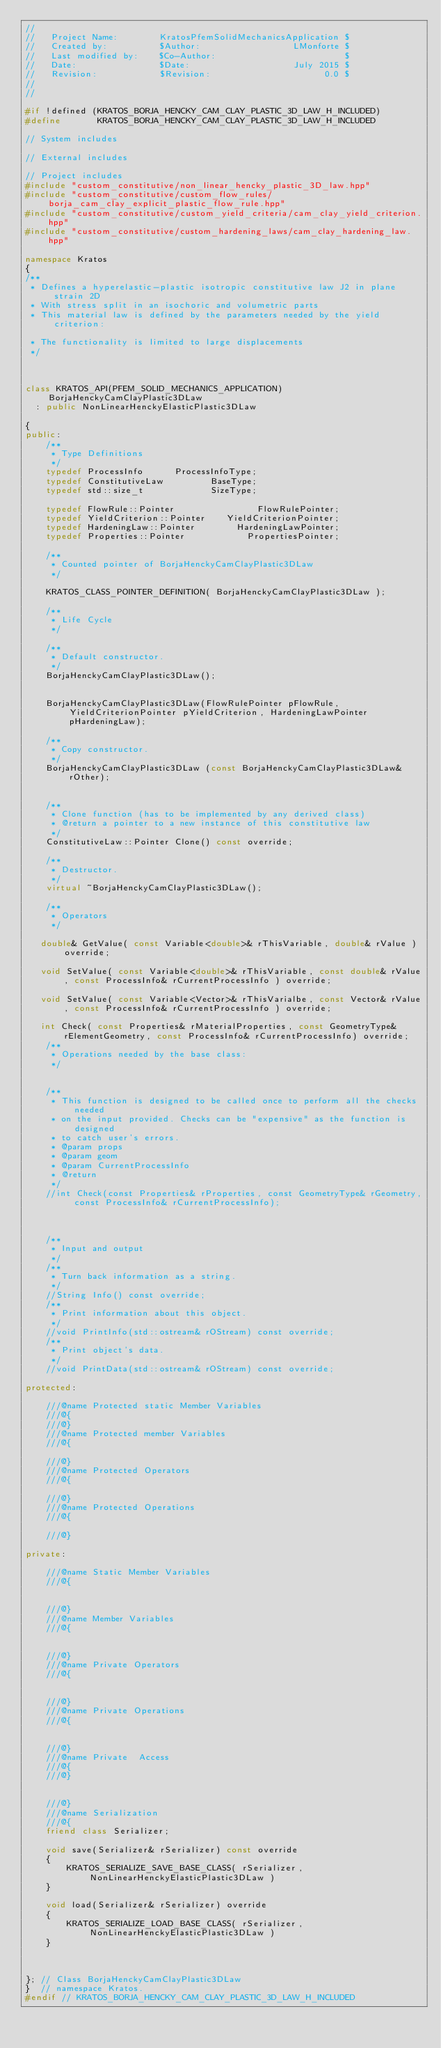Convert code to text. <code><loc_0><loc_0><loc_500><loc_500><_C++_>//
//   Project Name:        KratosPfemSolidMechanicsApplication $
//   Created by:          $Author:                  LMonforte $
//   Last modified by:    $Co-Author:                         $
//   Date:                $Date:                    July 2015 $
//   Revision:            $Revision:                      0.0 $
//
//

#if !defined (KRATOS_BORJA_HENCKY_CAM_CLAY_PLASTIC_3D_LAW_H_INCLUDED)
#define       KRATOS_BORJA_HENCKY_CAM_CLAY_PLASTIC_3D_LAW_H_INCLUDED

// System includes

// External includes

// Project includes
#include "custom_constitutive/non_linear_hencky_plastic_3D_law.hpp"
#include "custom_constitutive/custom_flow_rules/borja_cam_clay_explicit_plastic_flow_rule.hpp"
#include "custom_constitutive/custom_yield_criteria/cam_clay_yield_criterion.hpp"
#include "custom_constitutive/custom_hardening_laws/cam_clay_hardening_law.hpp"

namespace Kratos
{
/**
 * Defines a hyperelastic-plastic isotropic constitutive law J2 in plane strain 2D
 * With stress split in an isochoric and volumetric parts
 * This material law is defined by the parameters needed by the yield criterion:

 * The functionality is limited to large displacements
 */



class KRATOS_API(PFEM_SOLID_MECHANICS_APPLICATION) BorjaHenckyCamClayPlastic3DLaw
  : public NonLinearHenckyElasticPlastic3DLaw

{
public:
    /**
     * Type Definitions
     */
    typedef ProcessInfo      ProcessInfoType;
    typedef ConstitutiveLaw         BaseType;
    typedef std::size_t             SizeType;

    typedef FlowRule::Pointer                FlowRulePointer;
    typedef YieldCriterion::Pointer    YieldCriterionPointer;
    typedef HardeningLaw::Pointer        HardeningLawPointer;
    typedef Properties::Pointer            PropertiesPointer;

    /**
     * Counted pointer of BorjaHenckyCamClayPlastic3DLaw
     */

    KRATOS_CLASS_POINTER_DEFINITION( BorjaHenckyCamClayPlastic3DLaw );

    /**
     * Life Cycle
     */

    /**
     * Default constructor.
     */
    BorjaHenckyCamClayPlastic3DLaw();


    BorjaHenckyCamClayPlastic3DLaw(FlowRulePointer pFlowRule, YieldCriterionPointer pYieldCriterion, HardeningLawPointer pHardeningLaw);

    /**
     * Copy constructor.
     */
    BorjaHenckyCamClayPlastic3DLaw (const BorjaHenckyCamClayPlastic3DLaw& rOther);


    /**
     * Clone function (has to be implemented by any derived class)
     * @return a pointer to a new instance of this constitutive law
     */
    ConstitutiveLaw::Pointer Clone() const override;

    /**
     * Destructor.
     */
    virtual ~BorjaHenckyCamClayPlastic3DLaw();

    /**
     * Operators
     */

   double& GetValue( const Variable<double>& rThisVariable, double& rValue ) override;

   void SetValue( const Variable<double>& rThisVariable, const double& rValue, const ProcessInfo& rCurrentProcessInfo ) override;

   void SetValue( const Variable<Vector>& rThisVarialbe, const Vector& rValue, const ProcessInfo& rCurrentProcessInfo ) override;

   int Check( const Properties& rMaterialProperties, const GeometryType& rElementGeometry, const ProcessInfo& rCurrentProcessInfo) override;
    /**
     * Operations needed by the base class:
     */


    /**
     * This function is designed to be called once to perform all the checks needed
     * on the input provided. Checks can be "expensive" as the function is designed
     * to catch user's errors.
     * @param props
     * @param geom
     * @param CurrentProcessInfo
     * @return
     */
    //int Check(const Properties& rProperties, const GeometryType& rGeometry, const ProcessInfo& rCurrentProcessInfo);



    /**
     * Input and output
     */
    /**
     * Turn back information as a string.
     */
    //String Info() const override;
    /**
     * Print information about this object.
     */
    //void PrintInfo(std::ostream& rOStream) const override;
    /**
     * Print object's data.
     */
    //void PrintData(std::ostream& rOStream) const override;

protected:

    ///@name Protected static Member Variables
    ///@{
    ///@}
    ///@name Protected member Variables
    ///@{

    ///@}
    ///@name Protected Operators
    ///@{

    ///@}
    ///@name Protected Operations
    ///@{

    ///@}

private:

    ///@name Static Member Variables
    ///@{


    ///@}
    ///@name Member Variables
    ///@{


    ///@}
    ///@name Private Operators
    ///@{


    ///@}
    ///@name Private Operations
    ///@{


    ///@}
    ///@name Private  Access
    ///@{
    ///@}


    ///@}
    ///@name Serialization
    ///@{
    friend class Serializer;

    void save(Serializer& rSerializer) const override
    {
        KRATOS_SERIALIZE_SAVE_BASE_CLASS( rSerializer, NonLinearHenckyElasticPlastic3DLaw )
    }

    void load(Serializer& rSerializer) override
    {
        KRATOS_SERIALIZE_LOAD_BASE_CLASS( rSerializer, NonLinearHenckyElasticPlastic3DLaw )
    }



}; // Class BorjaHenckyCamClayPlastic3DLaw
}  // namespace Kratos.
#endif // KRATOS_BORJA_HENCKY_CAM_CLAY_PLASTIC_3D_LAW_H_INCLUDED
</code> 